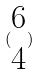<formula> <loc_0><loc_0><loc_500><loc_500>( \begin{matrix} 6 \\ 4 \end{matrix} )</formula> 